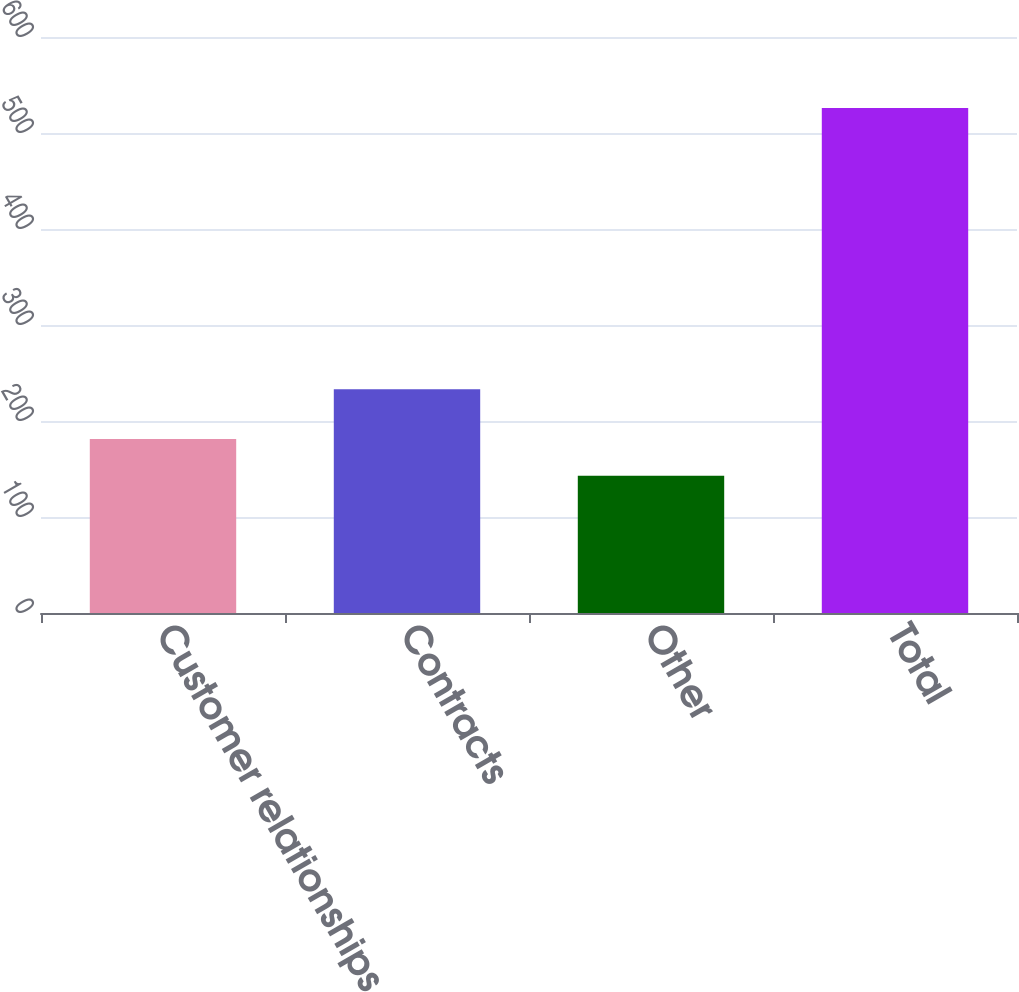<chart> <loc_0><loc_0><loc_500><loc_500><bar_chart><fcel>Customer relationships<fcel>Contracts<fcel>Other<fcel>Total<nl><fcel>181.3<fcel>233<fcel>143<fcel>526<nl></chart> 